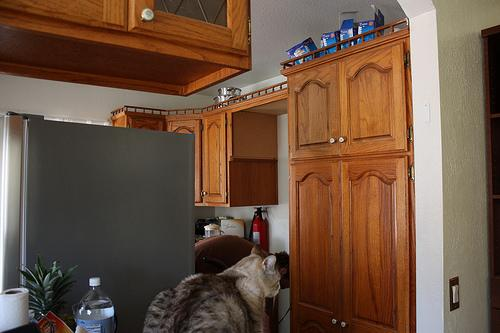Provide a short description of the fire safety item found in the kitchen. A red fire extinguisher is located behind the cat in the kitchen. Describe the cat's appearance in terms of color and size. The cat is large, with a grey head, brown face, and dark grey fur on its back. Describe the location and appearance of the kitchen light switch. The light switch is located on the wall near the drawer and is silver and white in color. Identify the primary animal in the picture and explain where it is located. A grey cat with a brown head and dark grey fur on its back is sitting in the kitchen on a counter. Name the fruits and any other items on the counter beside the main subject. There's a pineapple with green fronds and a bottle of water with a white top near the cat. Next to the pineapple are paper towels. What type of plant can be found in the kitchen, and what are its characteristics? A potted green plant with thick leaves can be found in the kitchen. Count the number of objects that are part of the kitchen cabinets. There are four objects related to the kitchen cabinets: a white knob, a wood and glass door, a brown cabinet door, and a tall wooden cabinet. What color is the refrigerator and what is on top of it? The refrigerator is grey, and there is a wooden cabinet on top of it. Mention the two different types of cabinets found in the kitchen. There are tall wooden cabinets and cabinets with wood and glass doors in the kitchen. List any items near the cat that might be for drinking. There is a bottle of water with a white top and a 2l bottle of clear liquid near the cat. What color is the fire extinguisher in the image? The fire extinguisher is red. Describe any anomalies within the image. There are no noticeable anomalies in the image. Transcribe any text visible in the image. No text is present in the image. Which object is closest to the cat? A bottle near the cat at X:69 Y:271 Width:47 Height:47. List the objects that are interacting with the cat. A person behind the cat and a bottle near the cat. Is there a roll of paper towels in the image? If so, where are they located? Yes, there's a white paper towel roll at X:0 Y:278 Width:41 Height:41. Rate the quality of the image from 1 to 10, where 1 is very low and 10 is very high. 7 What type of bottles are present in the image? A water bottle with a white top, tonic water behind the cat, and a 2L bottle of clear liquid on the counter. List the different colors of objects visible in the image. Grey, white, brown, red, silver, black, and green. How many objects are on the kitchen counter? There are at least 8 objects on the counter including the cat. Can you see any text on any object in the image? No, there is no visible text in the image. Determine the mood or sentiment of the image. Neutral, as it's a regular kitchen scene with no strong emotions. What kind of plant is depicted in the image? There's a potted green plant with thick leaves. What is the color of the refrigerator in the image? The refrigerator is gray. Identify the areas occupied by the kitchen cabinets in the image. Tall wooden cabinet at X:283 Y:59 Width:132 Height:132 and catchall top cabinet at X:279 Y:10 Width:135 Height:135. What type of door does the kitchen cupboard have? Wood and glass door at X:129 Y:0 Width:120 Height:120. Which object can be used to light up the kitchen out of the visible objects? The light switch. Which object is behind the cat? A red fire extinguisher is behind the cat. Describe the cat in the image. The cat is grey, with a brown head and dark grey fur on its back, sitting in the kitchen. 